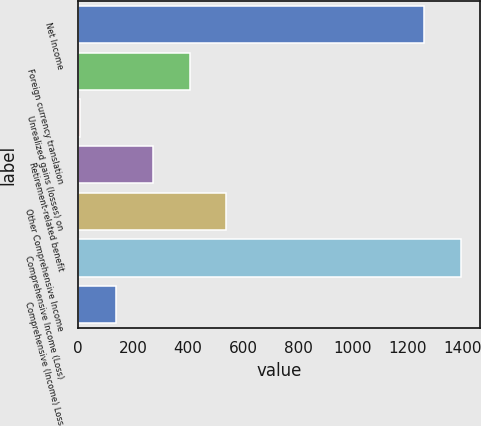Convert chart to OTSL. <chart><loc_0><loc_0><loc_500><loc_500><bar_chart><fcel>Net Income<fcel>Foreign currency translation<fcel>Unrealized gains (losses) on<fcel>Retirement-related benefit<fcel>Other Comprehensive Income<fcel>Comprehensive Income (Loss)<fcel>Comprehensive (Income) Loss<nl><fcel>1258<fcel>406.5<fcel>6<fcel>273<fcel>540<fcel>1391.5<fcel>139.5<nl></chart> 